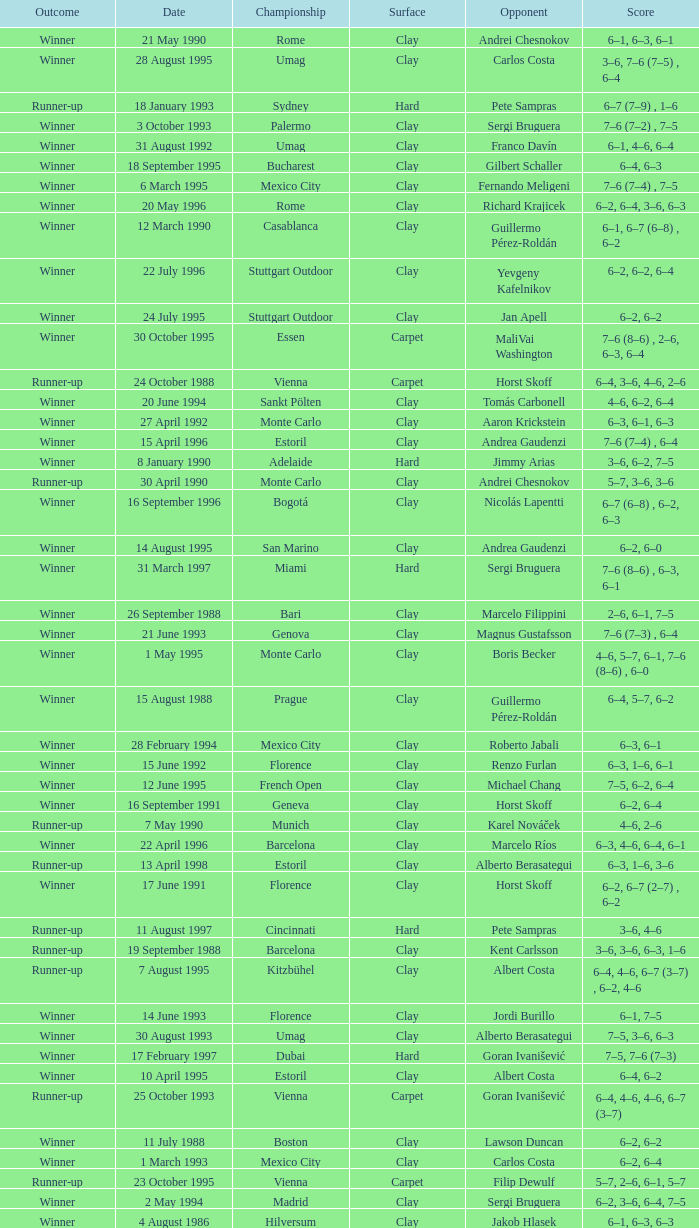Could you help me parse every detail presented in this table? {'header': ['Outcome', 'Date', 'Championship', 'Surface', 'Opponent', 'Score'], 'rows': [['Winner', '21 May 1990', 'Rome', 'Clay', 'Andrei Chesnokov', '6–1, 6–3, 6–1'], ['Winner', '28 August 1995', 'Umag', 'Clay', 'Carlos Costa', '3–6, 7–6 (7–5) , 6–4'], ['Runner-up', '18 January 1993', 'Sydney', 'Hard', 'Pete Sampras', '6–7 (7–9) , 1–6'], ['Winner', '3 October 1993', 'Palermo', 'Clay', 'Sergi Bruguera', '7–6 (7–2) , 7–5'], ['Winner', '31 August 1992', 'Umag', 'Clay', 'Franco Davín', '6–1, 4–6, 6–4'], ['Winner', '18 September 1995', 'Bucharest', 'Clay', 'Gilbert Schaller', '6–4, 6–3'], ['Winner', '6 March 1995', 'Mexico City', 'Clay', 'Fernando Meligeni', '7–6 (7–4) , 7–5'], ['Winner', '20 May 1996', 'Rome', 'Clay', 'Richard Krajicek', '6–2, 6–4, 3–6, 6–3'], ['Winner', '12 March 1990', 'Casablanca', 'Clay', 'Guillermo Pérez-Roldán', '6–1, 6–7 (6–8) , 6–2'], ['Winner', '22 July 1996', 'Stuttgart Outdoor', 'Clay', 'Yevgeny Kafelnikov', '6–2, 6–2, 6–4'], ['Winner', '24 July 1995', 'Stuttgart Outdoor', 'Clay', 'Jan Apell', '6–2, 6–2'], ['Winner', '30 October 1995', 'Essen', 'Carpet', 'MaliVai Washington', '7–6 (8–6) , 2–6, 6–3, 6–4'], ['Runner-up', '24 October 1988', 'Vienna', 'Carpet', 'Horst Skoff', '6–4, 3–6, 4–6, 2–6'], ['Winner', '20 June 1994', 'Sankt Pölten', 'Clay', 'Tomás Carbonell', '4–6, 6–2, 6–4'], ['Winner', '27 April 1992', 'Monte Carlo', 'Clay', 'Aaron Krickstein', '6–3, 6–1, 6–3'], ['Winner', '15 April 1996', 'Estoril', 'Clay', 'Andrea Gaudenzi', '7–6 (7–4) , 6–4'], ['Winner', '8 January 1990', 'Adelaide', 'Hard', 'Jimmy Arias', '3–6, 6–2, 7–5'], ['Runner-up', '30 April 1990', 'Monte Carlo', 'Clay', 'Andrei Chesnokov', '5–7, 3–6, 3–6'], ['Winner', '16 September 1996', 'Bogotá', 'Clay', 'Nicolás Lapentti', '6–7 (6–8) , 6–2, 6–3'], ['Winner', '14 August 1995', 'San Marino', 'Clay', 'Andrea Gaudenzi', '6–2, 6–0'], ['Winner', '31 March 1997', 'Miami', 'Hard', 'Sergi Bruguera', '7–6 (8–6) , 6–3, 6–1'], ['Winner', '26 September 1988', 'Bari', 'Clay', 'Marcelo Filippini', '2–6, 6–1, 7–5'], ['Winner', '21 June 1993', 'Genova', 'Clay', 'Magnus Gustafsson', '7–6 (7–3) , 6–4'], ['Winner', '1 May 1995', 'Monte Carlo', 'Clay', 'Boris Becker', '4–6, 5–7, 6–1, 7–6 (8–6) , 6–0'], ['Winner', '15 August 1988', 'Prague', 'Clay', 'Guillermo Pérez-Roldán', '6–4, 5–7, 6–2'], ['Winner', '28 February 1994', 'Mexico City', 'Clay', 'Roberto Jabali', '6–3, 6–1'], ['Winner', '15 June 1992', 'Florence', 'Clay', 'Renzo Furlan', '6–3, 1–6, 6–1'], ['Winner', '12 June 1995', 'French Open', 'Clay', 'Michael Chang', '7–5, 6–2, 6–4'], ['Winner', '16 September 1991', 'Geneva', 'Clay', 'Horst Skoff', '6–2, 6–4'], ['Runner-up', '7 May 1990', 'Munich', 'Clay', 'Karel Nováček', '4–6, 2–6'], ['Winner', '22 April 1996', 'Barcelona', 'Clay', 'Marcelo Ríos', '6–3, 4–6, 6–4, 6–1'], ['Runner-up', '13 April 1998', 'Estoril', 'Clay', 'Alberto Berasategui', '6–3, 1–6, 3–6'], ['Winner', '17 June 1991', 'Florence', 'Clay', 'Horst Skoff', '6–2, 6–7 (2–7) , 6–2'], ['Runner-up', '11 August 1997', 'Cincinnati', 'Hard', 'Pete Sampras', '3–6, 4–6'], ['Runner-up', '19 September 1988', 'Barcelona', 'Clay', 'Kent Carlsson', '3–6, 3–6, 6–3, 1–6'], ['Runner-up', '7 August 1995', 'Kitzbühel', 'Clay', 'Albert Costa', '6–4, 4–6, 6–7 (3–7) , 6–2, 4–6'], ['Winner', '14 June 1993', 'Florence', 'Clay', 'Jordi Burillo', '6–1, 7–5'], ['Winner', '30 August 1993', 'Umag', 'Clay', 'Alberto Berasategui', '7–5, 3–6, 6–3'], ['Winner', '17 February 1997', 'Dubai', 'Hard', 'Goran Ivanišević', '7–5, 7–6 (7–3)'], ['Winner', '10 April 1995', 'Estoril', 'Clay', 'Albert Costa', '6–4, 6–2'], ['Runner-up', '25 October 1993', 'Vienna', 'Carpet', 'Goran Ivanišević', '6–4, 4–6, 4–6, 6–7 (3–7)'], ['Winner', '11 July 1988', 'Boston', 'Clay', 'Lawson Duncan', '6–2, 6–2'], ['Winner', '1 March 1993', 'Mexico City', 'Clay', 'Carlos Costa', '6–2, 6–4'], ['Runner-up', '23 October 1995', 'Vienna', 'Carpet', 'Filip Dewulf', '5–7, 2–6, 6–1, 5–7'], ['Winner', '2 May 1994', 'Madrid', 'Clay', 'Sergi Bruguera', '6–2, 3–6, 6–4, 7–5'], ['Winner', '4 August 1986', 'Hilversum', 'Clay', 'Jakob Hlasek', '6–1, 6–3, 6–3'], ['Runner-up', '3 April 1989', 'Miami', 'Hard', 'Ivan Lendl', 'W/O'], ['Winner', '26 June 1995', 'Sankt Pölten', 'Clay', 'Bohdan Ulihrach', '6–3, 3–6, 6–1'], ['Winner', '17 April 1995', 'Barcelona', 'Clay', 'Magnus Larsson', '6–2, 6–1, 6–4'], ['Winner', '11 March 1996', 'Mexico City', 'Clay', 'Jiří Novák', '7–6 (7–3) , 6–2'], ['Winner', '9 August 1993', 'Kitzbühel', 'Clay', 'Javier Sánchez', '6–3, 7–5, 6–4'], ['Winner', '1 August 1988', 'Bordeaux', 'Clay', 'Ronald Agénor', '6–3, 6–3'], ['Winner', '29 April 1996', 'Monte Carlo', 'Clay', 'Albert Costa', '6–3, 5–7, 4–6, 6–3, 6–2'], ['Winner', '16 August 1993', 'San Marino', 'Clay', 'Renzo Furlan', '7–5, 7–5'], ['Winner', '22 May 1995', 'Rome', 'Clay', 'Sergi Bruguera', '3–6, 7–6 (7–5) , 6–2, 6–3']]} Who is the opponent on 18 january 1993? Pete Sampras. 